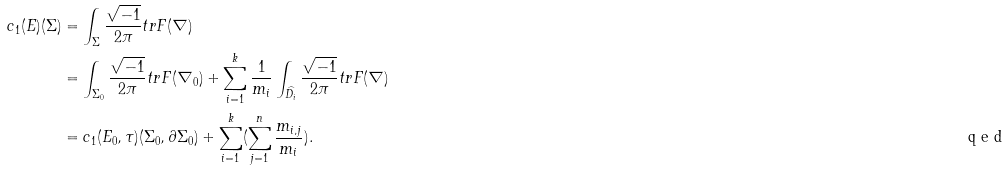Convert formula to latex. <formula><loc_0><loc_0><loc_500><loc_500>c _ { 1 } ( E ) ( \Sigma ) & = \int _ { \Sigma } \frac { \sqrt { - 1 } } { 2 \pi } t r F ( \nabla ) \\ & = \int _ { \Sigma _ { 0 } } \frac { \sqrt { - 1 } } { 2 \pi } t r F ( \nabla _ { 0 } ) + \sum _ { i = 1 } ^ { k } \frac { 1 } { m _ { i } } \int _ { \widehat { D _ { i } } } \frac { \sqrt { - 1 } } { 2 \pi } t r F ( \nabla ) \\ & = c _ { 1 } ( E _ { 0 } , \tau ) ( \Sigma _ { 0 } , \partial \Sigma _ { 0 } ) + \sum _ { i = 1 } ^ { k } ( \sum _ { j = 1 } ^ { n } \frac { m _ { i , j } } { m _ { i } } ) . \tag* { \ q e d }</formula> 